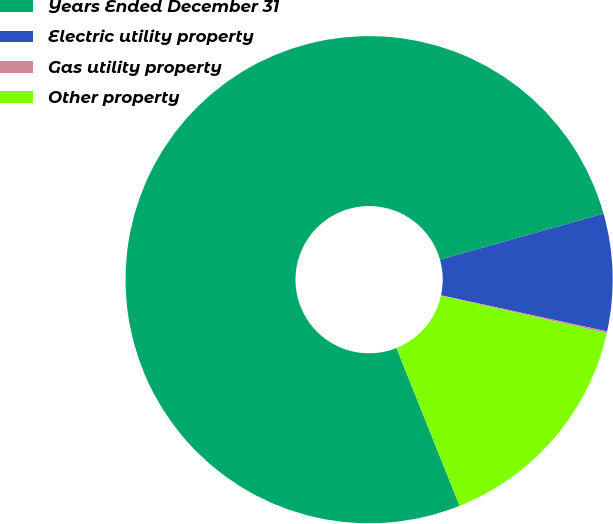Convert chart. <chart><loc_0><loc_0><loc_500><loc_500><pie_chart><fcel>Years Ended December 31<fcel>Electric utility property<fcel>Gas utility property<fcel>Other property<nl><fcel>76.69%<fcel>7.77%<fcel>0.11%<fcel>15.43%<nl></chart> 